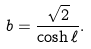Convert formula to latex. <formula><loc_0><loc_0><loc_500><loc_500>b = \frac { \sqrt { 2 } } { \cosh \ell } .</formula> 